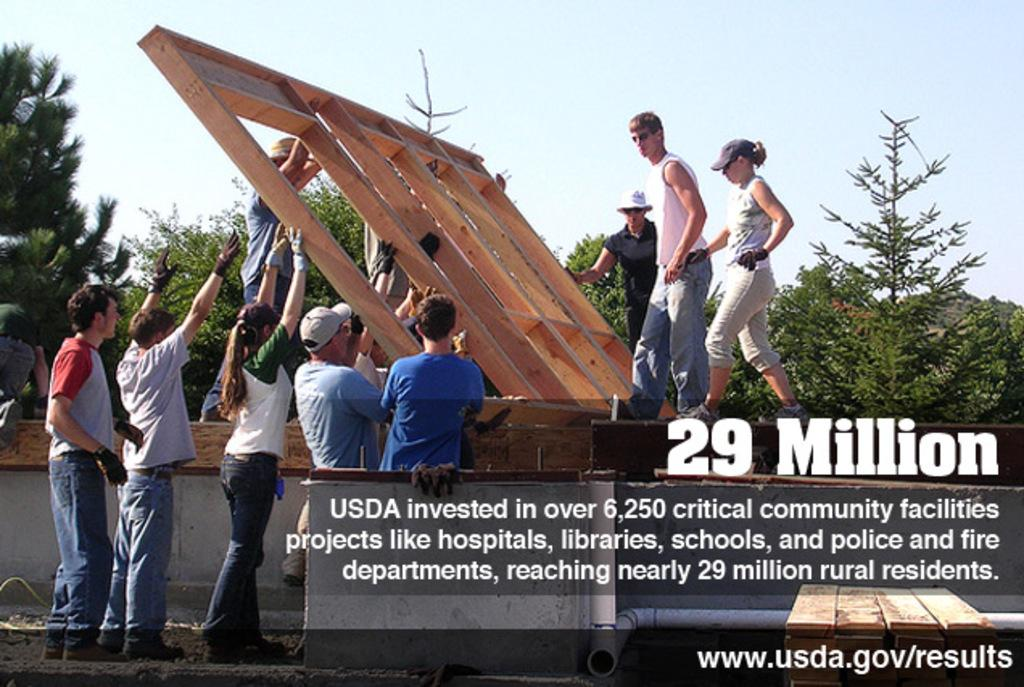What can be found at the bottom of the picture? There is text at the bottom of the picture. What is the main focus of the picture? There are people and construction activity in the center of the picture. What type of object is present in the center of the picture? There is a wooden object in the center of the picture. What can be seen in the background of the picture? There are trees in the background of the picture. How would you describe the weather in the picture? The sky is sunny, indicating good weather. Can you describe the texture of the wish in the picture? There is no wish present in the image, so it is not possible to describe its texture. How many people are smiling in the picture? The provided facts do not mention anyone smiling in the picture, so it is not possible to answer this question. 